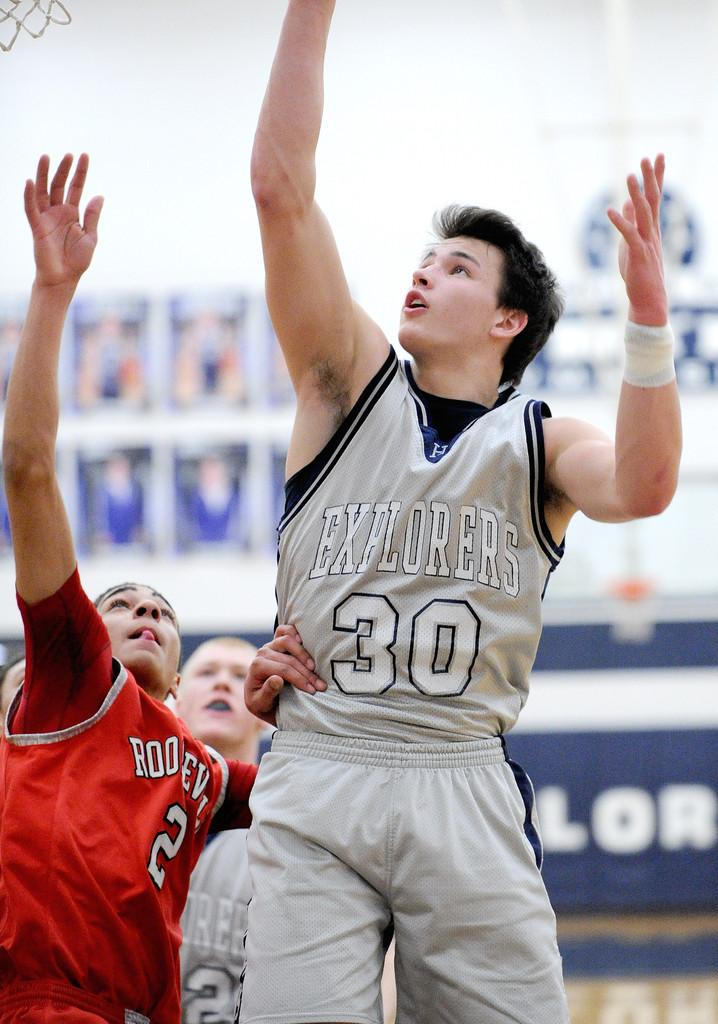<image>
Share a concise interpretation of the image provided. a bunch of people playing basketball, one of whom has the number thirty on his shirt. 